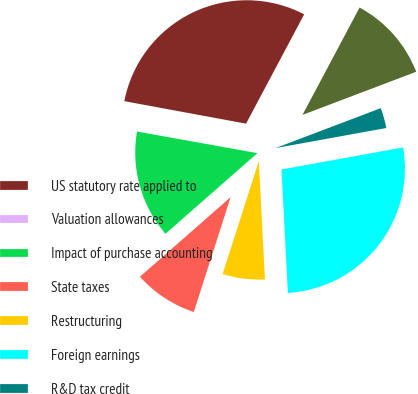Convert chart. <chart><loc_0><loc_0><loc_500><loc_500><pie_chart><fcel>US statutory rate applied to<fcel>Valuation allowances<fcel>Impact of purchase accounting<fcel>State taxes<fcel>Restructuring<fcel>Foreign earnings<fcel>R&D tax credit<fcel>Other (1)<nl><fcel>29.87%<fcel>0.08%<fcel>14.29%<fcel>8.6%<fcel>5.76%<fcel>27.03%<fcel>2.92%<fcel>11.45%<nl></chart> 